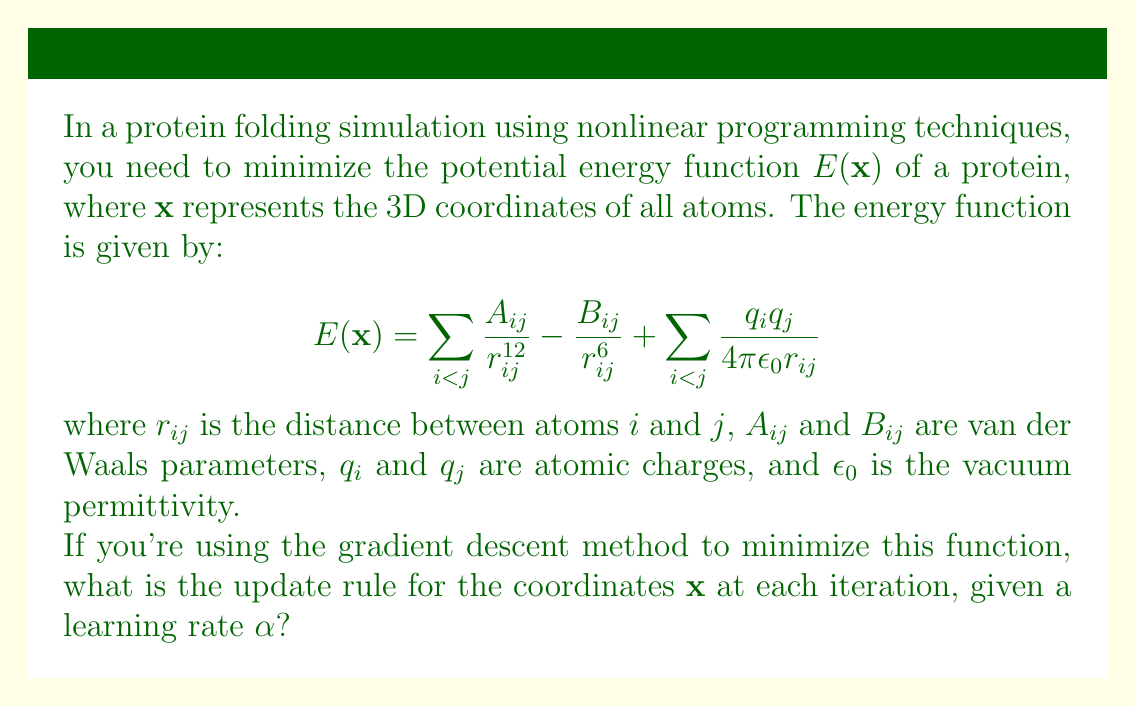Show me your answer to this math problem. To solve this problem, we need to follow these steps:

1. Recall the general update rule for gradient descent:
   $$\mathbf{x}_{new} = \mathbf{x}_{old} - \alpha \nabla E(\mathbf{x}_{old})$$

2. Calculate the gradient of the energy function $\nabla E(\mathbf{x})$:
   $$\nabla E(\mathbf{x}) = \sum_{i<j} \left(-12\frac{A_{ij}}{r_{ij}^{13}} + 6\frac{B_{ij}}{r_{ij}^7} - \frac{q_i q_j}{4\pi\epsilon_0 r_{ij}^2}\right) \nabla r_{ij}$$

3. Note that $\nabla r_{ij}$ is the unit vector pointing from atom $i$ to atom $j$:
   $$\nabla r_{ij} = \frac{\mathbf{x}_j - \mathbf{x}_i}{r_{ij}}$$

4. Substitute the gradient into the update rule:
   $$\mathbf{x}_{new} = \mathbf{x}_{old} - \alpha \sum_{i<j} \left(-12\frac{A_{ij}}{r_{ij}^{13}} + 6\frac{B_{ij}}{r_{ij}^7} - \frac{q_i q_j}{4\pi\epsilon_0 r_{ij}^2}\right) \frac{\mathbf{x}_j - \mathbf{x}_i}{r_{ij}}$$

This is the update rule for the coordinates $\mathbf{x}$ at each iteration of the gradient descent method for minimizing the given potential energy function.
Answer: $$\mathbf{x}_{new} = \mathbf{x}_{old} - \alpha \sum_{i<j} \left(-12\frac{A_{ij}}{r_{ij}^{13}} + 6\frac{B_{ij}}{r_{ij}^7} - \frac{q_i q_j}{4\pi\epsilon_0 r_{ij}^2}\right) \frac{\mathbf{x}_j - \mathbf{x}_i}{r_{ij}}$$ 